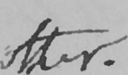What text is written in this handwritten line? other . 